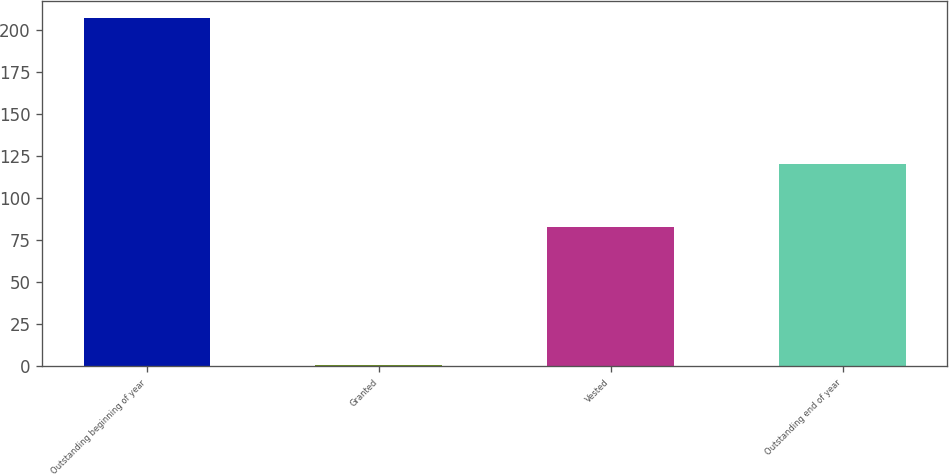<chart> <loc_0><loc_0><loc_500><loc_500><bar_chart><fcel>Outstanding beginning of year<fcel>Granted<fcel>Vested<fcel>Outstanding end of year<nl><fcel>207<fcel>1<fcel>83<fcel>120<nl></chart> 